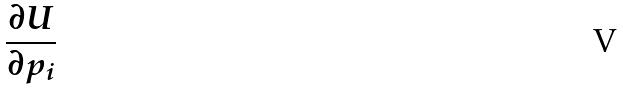<formula> <loc_0><loc_0><loc_500><loc_500>\frac { \partial U } { \partial p _ { i } }</formula> 